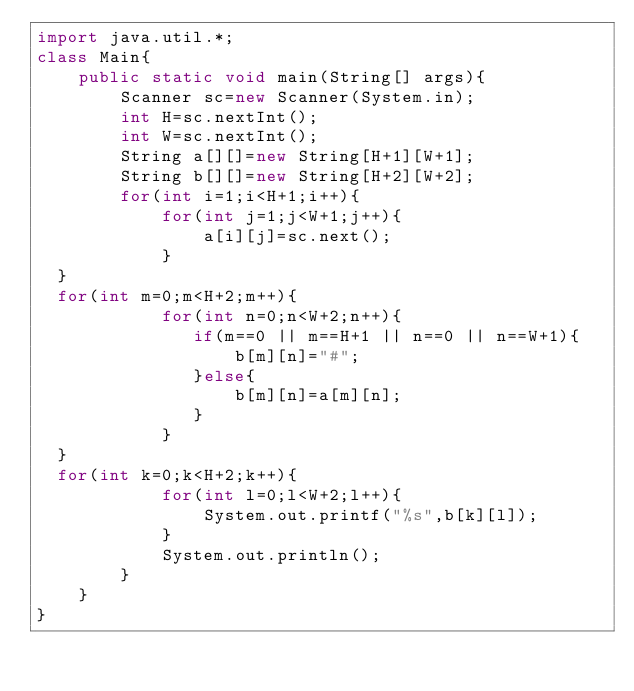Convert code to text. <code><loc_0><loc_0><loc_500><loc_500><_Java_>import java.util.*;
class Main{
    public static void main(String[] args){
        Scanner sc=new Scanner(System.in);
        int H=sc.nextInt();
        int W=sc.nextInt();
        String a[][]=new String[H+1][W+1];
        String b[][]=new String[H+2][W+2];
        for(int i=1;i<H+1;i++){
            for(int j=1;j<W+1;j++){
                a[i][j]=sc.next();
            }
	}
	for(int m=0;m<H+2;m++){
            for(int n=0;n<W+2;n++){
               if(m==0 || m==H+1 || n==0 || n==W+1){
                   b[m][n]="#";
               }else{
                   b[m][n]=a[m][n];
               }
            }
	}
	for(int k=0;k<H+2;k++){
            for(int l=0;l<W+2;l++){
                System.out.printf("%s",b[k][l]);
            }
            System.out.println();
        }
    }
}
</code> 